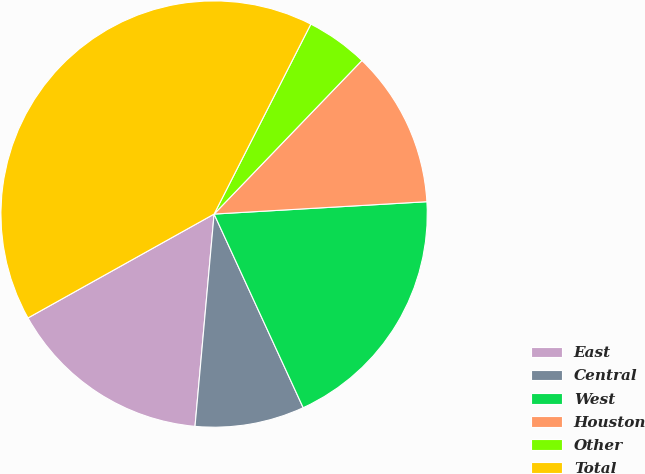Convert chart. <chart><loc_0><loc_0><loc_500><loc_500><pie_chart><fcel>East<fcel>Central<fcel>West<fcel>Houston<fcel>Other<fcel>Total<nl><fcel>15.47%<fcel>8.29%<fcel>19.06%<fcel>11.88%<fcel>4.7%<fcel>40.6%<nl></chart> 